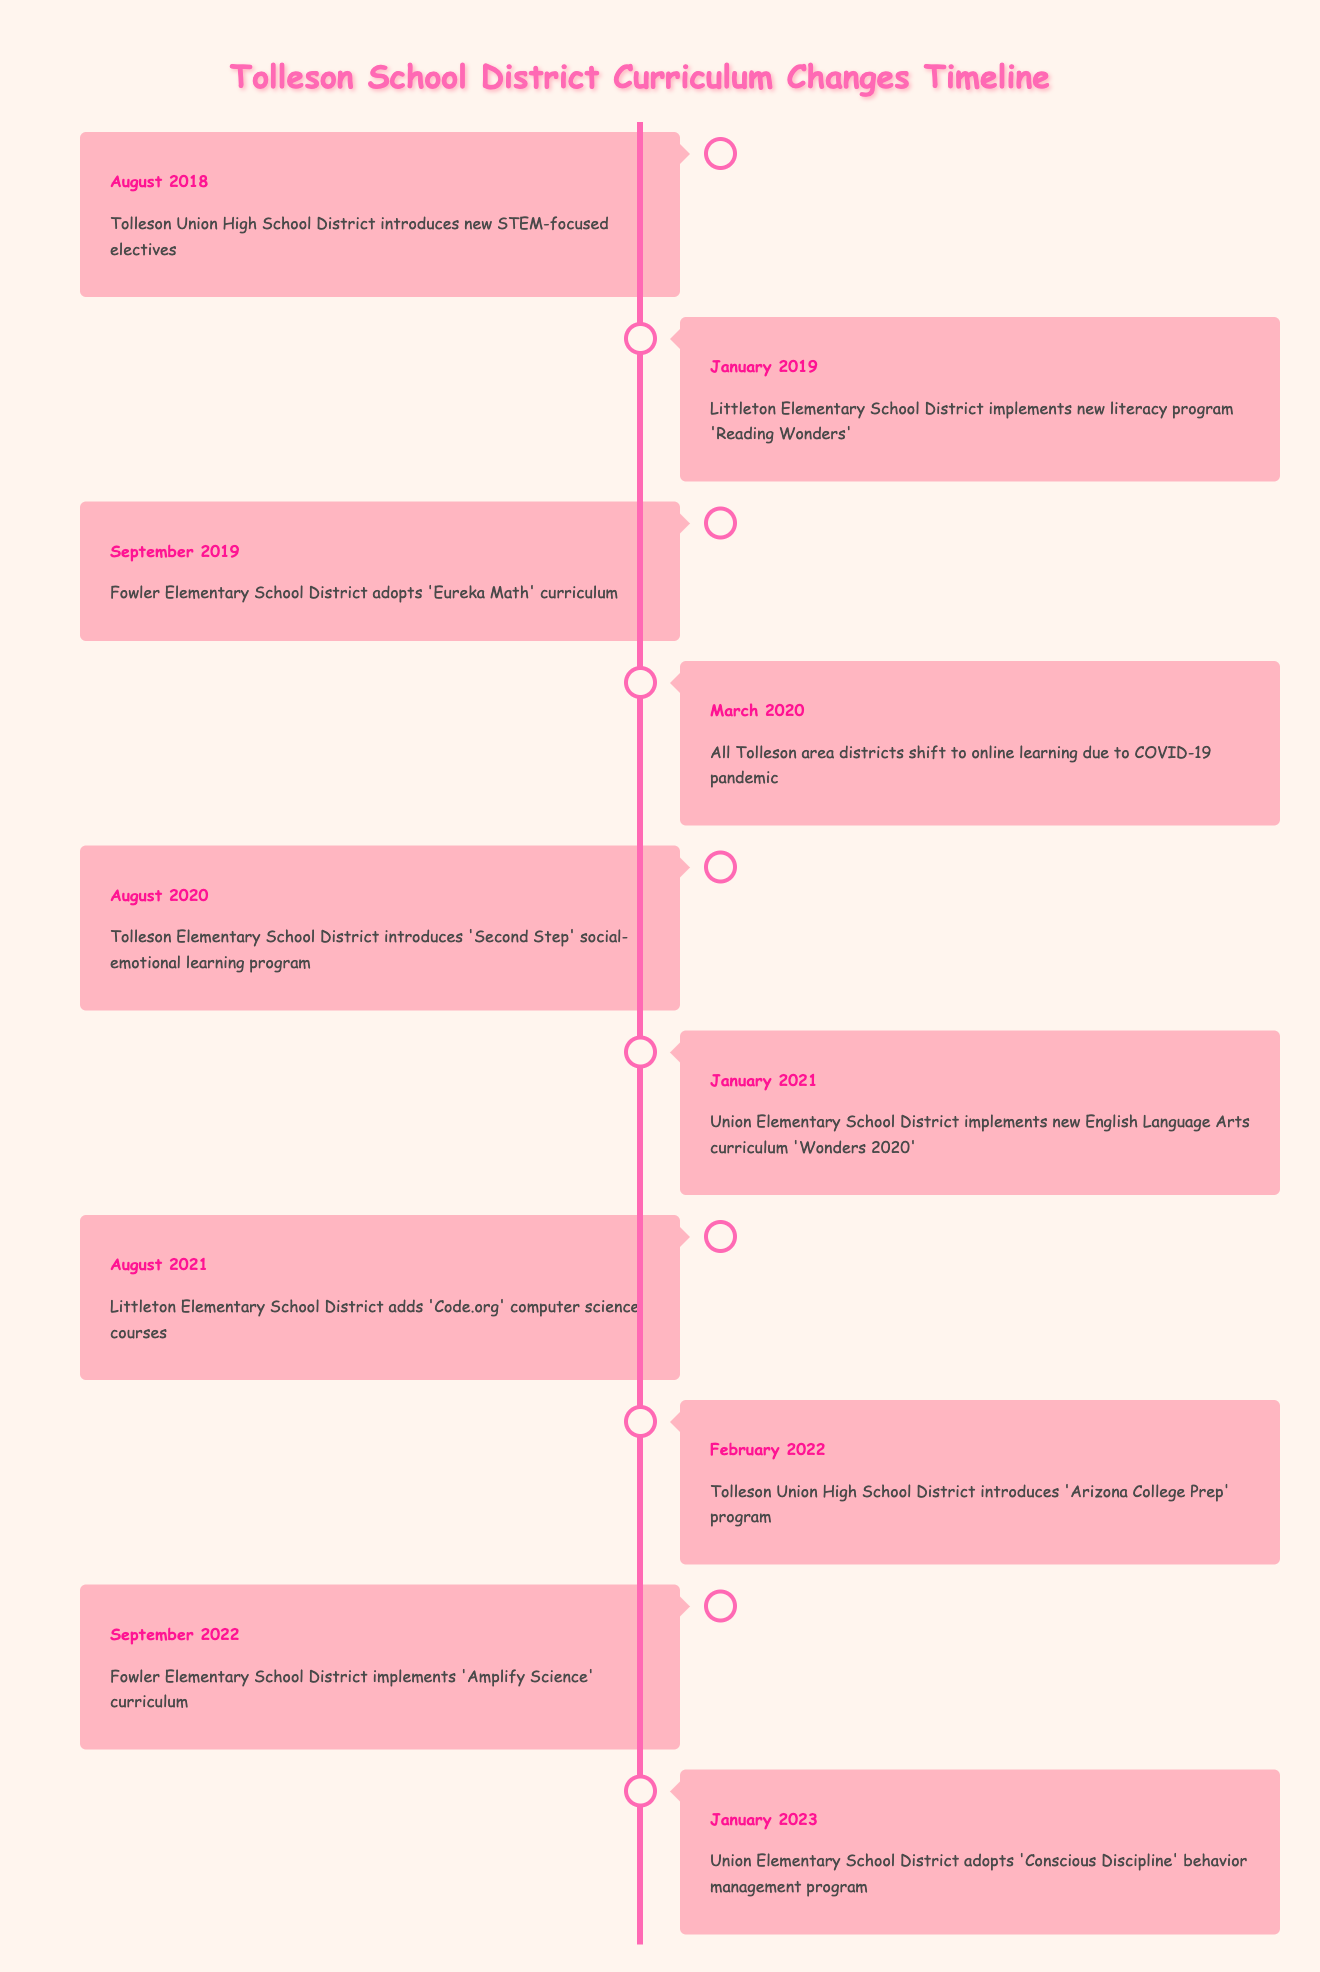What curriculum change was introduced in August 2020? According to the timeline, in August 2020, the Tolleson Elementary School District introduced the 'Second Step' social-emotional learning program.
Answer: 'Second Step' social-emotional learning program How many curriculum changes occurred in 2019? In the provided timeline, there are two events listed for 2019: one in January (Littleton Elementary School District) and one in September (Fowler Elementary School District), totaling two changes.
Answer: 2 Was 'Eureka Math' adopted before or after the COVID-19 pandemic began? 'Eureka Math' was adopted in September 2019, and the COVID-19 pandemic prompted a shift to online learning in March 2020, thus 'Eureka Math' was adopted before the pandemic began.
Answer: Before What is the date of adoption for 'Conscious Discipline'? The table indicates that 'Conscious Discipline' was adopted by Union Elementary School District in January 2023.
Answer: January 2023 Which school district introduced a computer science course in August 2021? The timeline shows that in August 2021, Littleton Elementary School District added 'Code.org' computer science courses.
Answer: Littleton Elementary School District Which program was introduced more recently: the 'Second Step' program or the 'Arizona College Prep' program? 'Second Step' was introduced in August 2020 and 'Arizona College Prep' in February 2022. Comparing the dates, 'Arizona College Prep' was introduced more recently than 'Second Step'.
Answer: 'Arizona College Prep' What is the difference in months between the introduction of 'Reading Wonders' and 'Wonders 2020'? 'Reading Wonders' was implemented in January 2019, while 'Wonders 2020' was introduced in January 2021. There is a difference of 12 months between these two programs.
Answer: 12 months Was 'Amplify Science' implemented by Fowler Elementary School District? Yes, according to the timeline, Fowler Elementary School District implemented 'Amplify Science' curriculum in September 2022.
Answer: Yes How many events in the timeline relate to social-emotional learning programs? There are two events related to social-emotional learning programs: the introduction of 'Second Step' in August 2020 and 'Conscious Discipline' in January 2023. Therefore, there are a total of two events related to this theme.
Answer: 2 